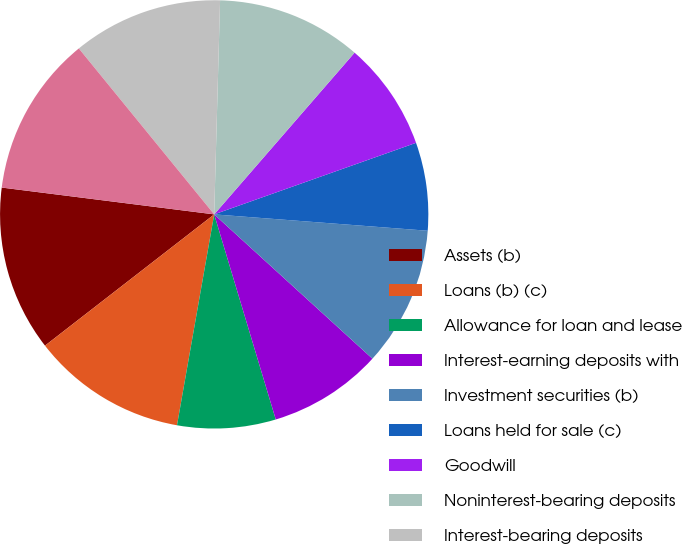<chart> <loc_0><loc_0><loc_500><loc_500><pie_chart><fcel>Assets (b)<fcel>Loans (b) (c)<fcel>Allowance for loan and lease<fcel>Interest-earning deposits with<fcel>Investment securities (b)<fcel>Loans held for sale (c)<fcel>Goodwill<fcel>Noninterest-bearing deposits<fcel>Interest-bearing deposits<fcel>Total deposits<nl><fcel>12.5%<fcel>11.72%<fcel>7.42%<fcel>8.59%<fcel>10.55%<fcel>6.64%<fcel>8.2%<fcel>10.94%<fcel>11.33%<fcel>12.11%<nl></chart> 